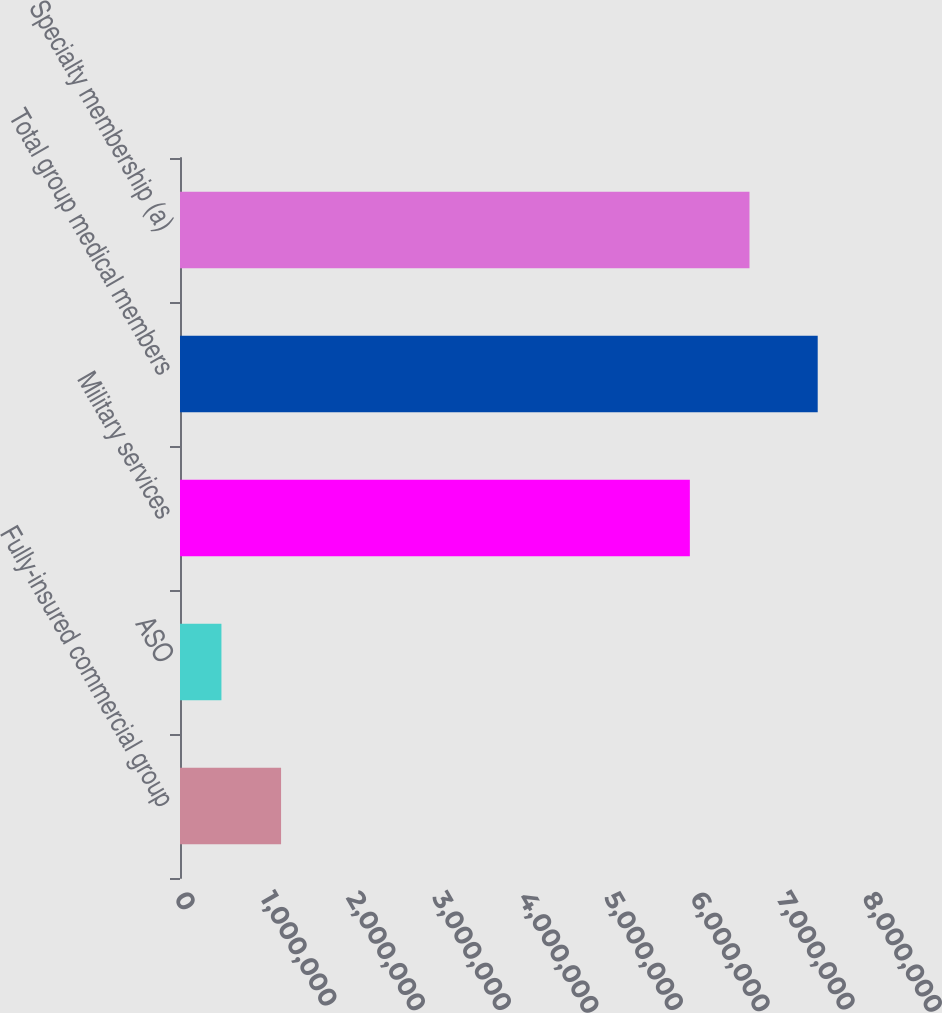Convert chart. <chart><loc_0><loc_0><loc_500><loc_500><bar_chart><fcel>Fully-insured commercial group<fcel>ASO<fcel>Military services<fcel>Total group medical members<fcel>Specialty membership (a)<nl><fcel>1.17523e+06<fcel>481900<fcel>5.9286e+06<fcel>7.4152e+06<fcel>6.62193e+06<nl></chart> 